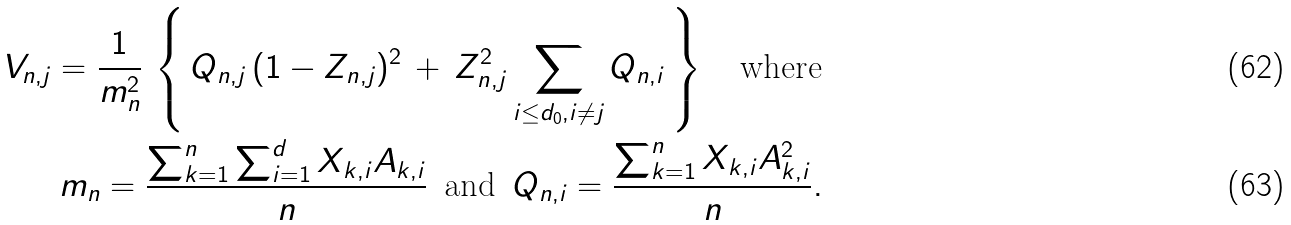<formula> <loc_0><loc_0><loc_500><loc_500>V _ { n , j } = \frac { 1 } { m _ { n } ^ { 2 } } \, \left \{ \, Q _ { n , j } \, ( 1 - Z _ { n , j } ) ^ { 2 } \, + \, Z _ { n , j } ^ { 2 } \sum _ { i \leq d _ { 0 } , i \neq j } Q _ { n , i } \, \right \} \quad \text {where} \\ m _ { n } = \frac { \sum _ { k = 1 } ^ { n } \sum _ { i = 1 } ^ { d } X _ { k , i } A _ { k , i } } { n } \, \text { and } \, Q _ { n , i } = \frac { \sum _ { k = 1 } ^ { n } X _ { k , i } A _ { k , i } ^ { 2 } } { n } .</formula> 